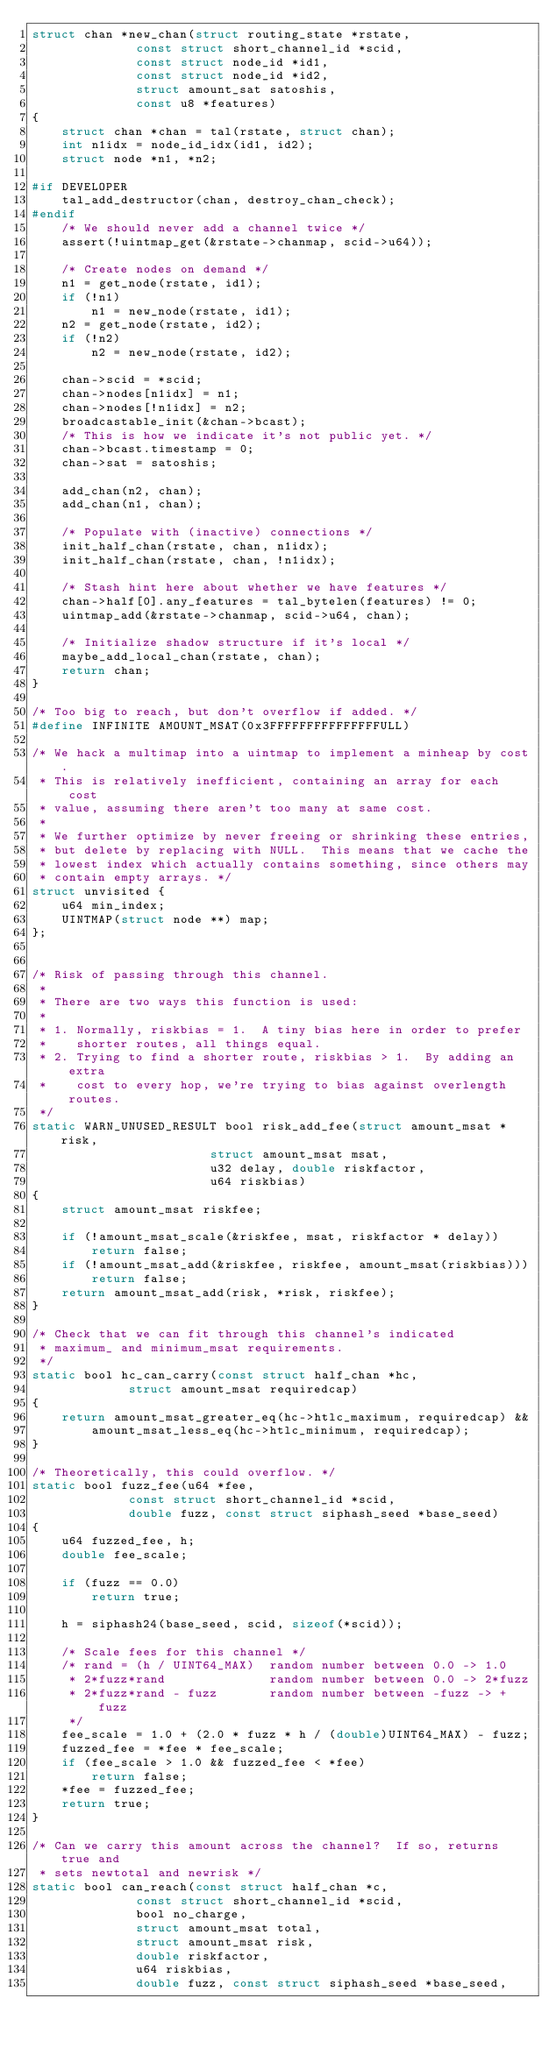<code> <loc_0><loc_0><loc_500><loc_500><_C_>struct chan *new_chan(struct routing_state *rstate,
		      const struct short_channel_id *scid,
		      const struct node_id *id1,
		      const struct node_id *id2,
		      struct amount_sat satoshis,
		      const u8 *features)
{
	struct chan *chan = tal(rstate, struct chan);
	int n1idx = node_id_idx(id1, id2);
	struct node *n1, *n2;

#if DEVELOPER
	tal_add_destructor(chan, destroy_chan_check);
#endif
	/* We should never add a channel twice */
	assert(!uintmap_get(&rstate->chanmap, scid->u64));

	/* Create nodes on demand */
	n1 = get_node(rstate, id1);
	if (!n1)
		n1 = new_node(rstate, id1);
	n2 = get_node(rstate, id2);
	if (!n2)
		n2 = new_node(rstate, id2);

	chan->scid = *scid;
	chan->nodes[n1idx] = n1;
	chan->nodes[!n1idx] = n2;
	broadcastable_init(&chan->bcast);
	/* This is how we indicate it's not public yet. */
	chan->bcast.timestamp = 0;
	chan->sat = satoshis;

	add_chan(n2, chan);
	add_chan(n1, chan);

	/* Populate with (inactive) connections */
	init_half_chan(rstate, chan, n1idx);
	init_half_chan(rstate, chan, !n1idx);

	/* Stash hint here about whether we have features */
	chan->half[0].any_features = tal_bytelen(features) != 0;
	uintmap_add(&rstate->chanmap, scid->u64, chan);

	/* Initialize shadow structure if it's local */
	maybe_add_local_chan(rstate, chan);
	return chan;
}

/* Too big to reach, but don't overflow if added. */
#define INFINITE AMOUNT_MSAT(0x3FFFFFFFFFFFFFFFULL)

/* We hack a multimap into a uintmap to implement a minheap by cost.
 * This is relatively inefficient, containing an array for each cost
 * value, assuming there aren't too many at same cost.
 *
 * We further optimize by never freeing or shrinking these entries,
 * but delete by replacing with NULL.  This means that we cache the
 * lowest index which actually contains something, since others may
 * contain empty arrays. */
struct unvisited {
	u64 min_index;
	UINTMAP(struct node **) map;
};


/* Risk of passing through this channel.
 *
 * There are two ways this function is used:
 *
 * 1. Normally, riskbias = 1.  A tiny bias here in order to prefer
 *    shorter routes, all things equal.
 * 2. Trying to find a shorter route, riskbias > 1.  By adding an extra
 *    cost to every hop, we're trying to bias against overlength routes.
 */
static WARN_UNUSED_RESULT bool risk_add_fee(struct amount_msat *risk,
					    struct amount_msat msat,
					    u32 delay, double riskfactor,
					    u64 riskbias)
{
	struct amount_msat riskfee;

	if (!amount_msat_scale(&riskfee, msat, riskfactor * delay))
		return false;
	if (!amount_msat_add(&riskfee, riskfee, amount_msat(riskbias)))
		return false;
	return amount_msat_add(risk, *risk, riskfee);
}

/* Check that we can fit through this channel's indicated
 * maximum_ and minimum_msat requirements.
 */
static bool hc_can_carry(const struct half_chan *hc,
			 struct amount_msat requiredcap)
{
	return amount_msat_greater_eq(hc->htlc_maximum, requiredcap) &&
		amount_msat_less_eq(hc->htlc_minimum, requiredcap);
}

/* Theoretically, this could overflow. */
static bool fuzz_fee(u64 *fee,
		     const struct short_channel_id *scid,
		     double fuzz, const struct siphash_seed *base_seed)
{
	u64 fuzzed_fee, h;
 	double fee_scale;

	if (fuzz == 0.0)
		return true;

	h = siphash24(base_seed, scid, sizeof(*scid));

	/* Scale fees for this channel */
	/* rand = (h / UINT64_MAX)  random number between 0.0 -> 1.0
	 * 2*fuzz*rand              random number between 0.0 -> 2*fuzz
	 * 2*fuzz*rand - fuzz       random number between -fuzz -> +fuzz
	 */
	fee_scale = 1.0 + (2.0 * fuzz * h / (double)UINT64_MAX) - fuzz;
	fuzzed_fee = *fee * fee_scale;
	if (fee_scale > 1.0 && fuzzed_fee < *fee)
		return false;
	*fee = fuzzed_fee;
	return true;
}

/* Can we carry this amount across the channel?  If so, returns true and
 * sets newtotal and newrisk */
static bool can_reach(const struct half_chan *c,
		      const struct short_channel_id *scid,
		      bool no_charge,
		      struct amount_msat total,
		      struct amount_msat risk,
		      double riskfactor,
		      u64 riskbias,
		      double fuzz, const struct siphash_seed *base_seed,</code> 